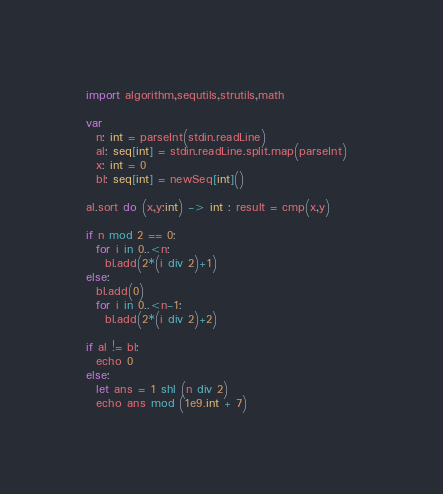Convert code to text. <code><loc_0><loc_0><loc_500><loc_500><_Nim_>import algorithm,sequtils,strutils,math

var
  n: int = parseInt(stdin.readLine)
  al: seq[int] = stdin.readLine.split.map(parseInt)  
  x: int = 0
  bl: seq[int] = newSeq[int]()

al.sort do (x,y:int) -> int : result = cmp(x,y)

if n mod 2 == 0:
  for i in 0..<n:
    bl.add(2*(i div 2)+1)
else:
  bl.add(0)
  for i in 0..<n-1:
    bl.add(2*(i div 2)+2)
    
if al != bl:
  echo 0
else:
  let ans = 1 shl (n div 2)
  echo ans mod (1e9.int + 7)</code> 